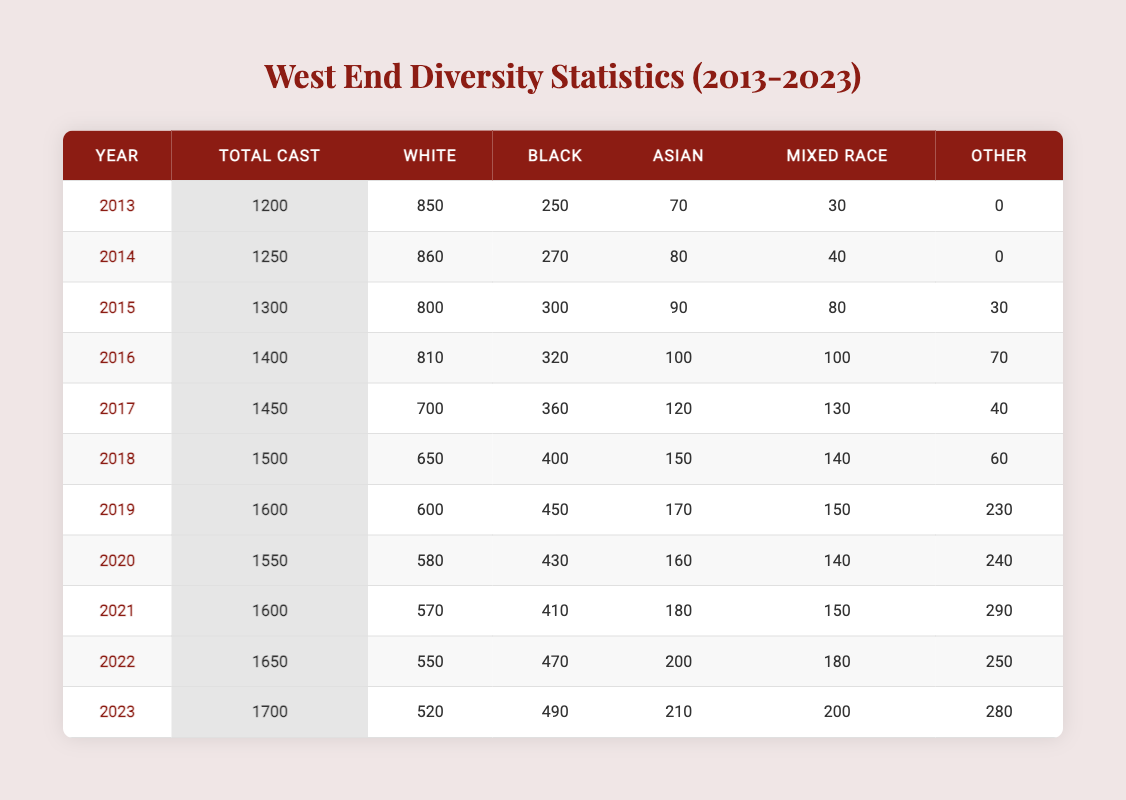What was the total number of total cast members in 2016? According to the table, the total number of cast members in 2016 is located in the row corresponding to that year, which states a total of 1400 cast members.
Answer: 1400 How many black actors were there in 2022? By checking the row for 2022, the number of black actors listed is 470.
Answer: 470 What is the average number of white actors from 2019 to 2023? First, identify the total number of white actors from 2019 (600), 2020 (580), 2021 (570), 2022 (550), and 2023 (520). Sum these: 600 + 580 + 570 + 550 + 520 = 2920. There are 5 years, so the average is 2920 / 5 = 584.
Answer: 584 Was there an increase in the number of mixed-race actors from 2017 to 2018? In 2017, there were 130 mixed-race actors and in 2018, there were 140. Since 140 is greater than 130, it indicates an increase.
Answer: Yes Which year had the highest number of total cast members, and how many were there? The highest total cast members can be found by reviewing the total cast figures for each year. The year 2023 had 1700 cast members, which is the highest compared to other years.
Answer: 2023, 1700 What is the difference in the number of Asian actors from 2015 to 2020? In 2015, there were 90 Asian actors, while in 2020, there were 160. The difference is calculated by subtracting: 160 - 90 = 70.
Answer: 70 How many total cast members were represented for other ethnicities in 2015? The table shows that in 2015 there were 30 cast members under the category of other ethnicities.
Answer: 30 Did the number of total cast members increase every year from 2013 to 2023? By examining the total cast numbers, the figures show a consistent increase each year: 1200 (2013), 1250 (2014), 1300 (2015), and so on until 1700 in 2023. Thus, the statement is true.
Answer: Yes What is the total count of black and mixed-race actors in 2021? For 2021, the count of black actors is 410 and mixed-race actors is 150. Adding these gives: 410 + 150 = 560.
Answer: 560 